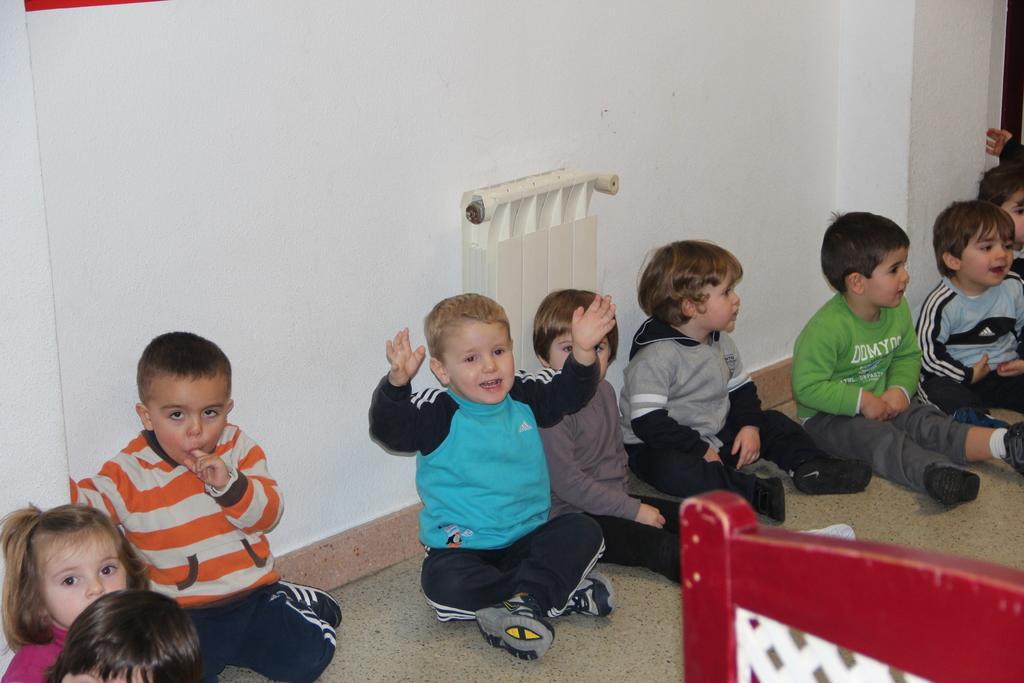In one or two sentences, can you explain what this image depicts? In the bottom right corner of the image we can see a chair. In the middle of the image few kids are sitting and smiling. Behind them there is wall. 